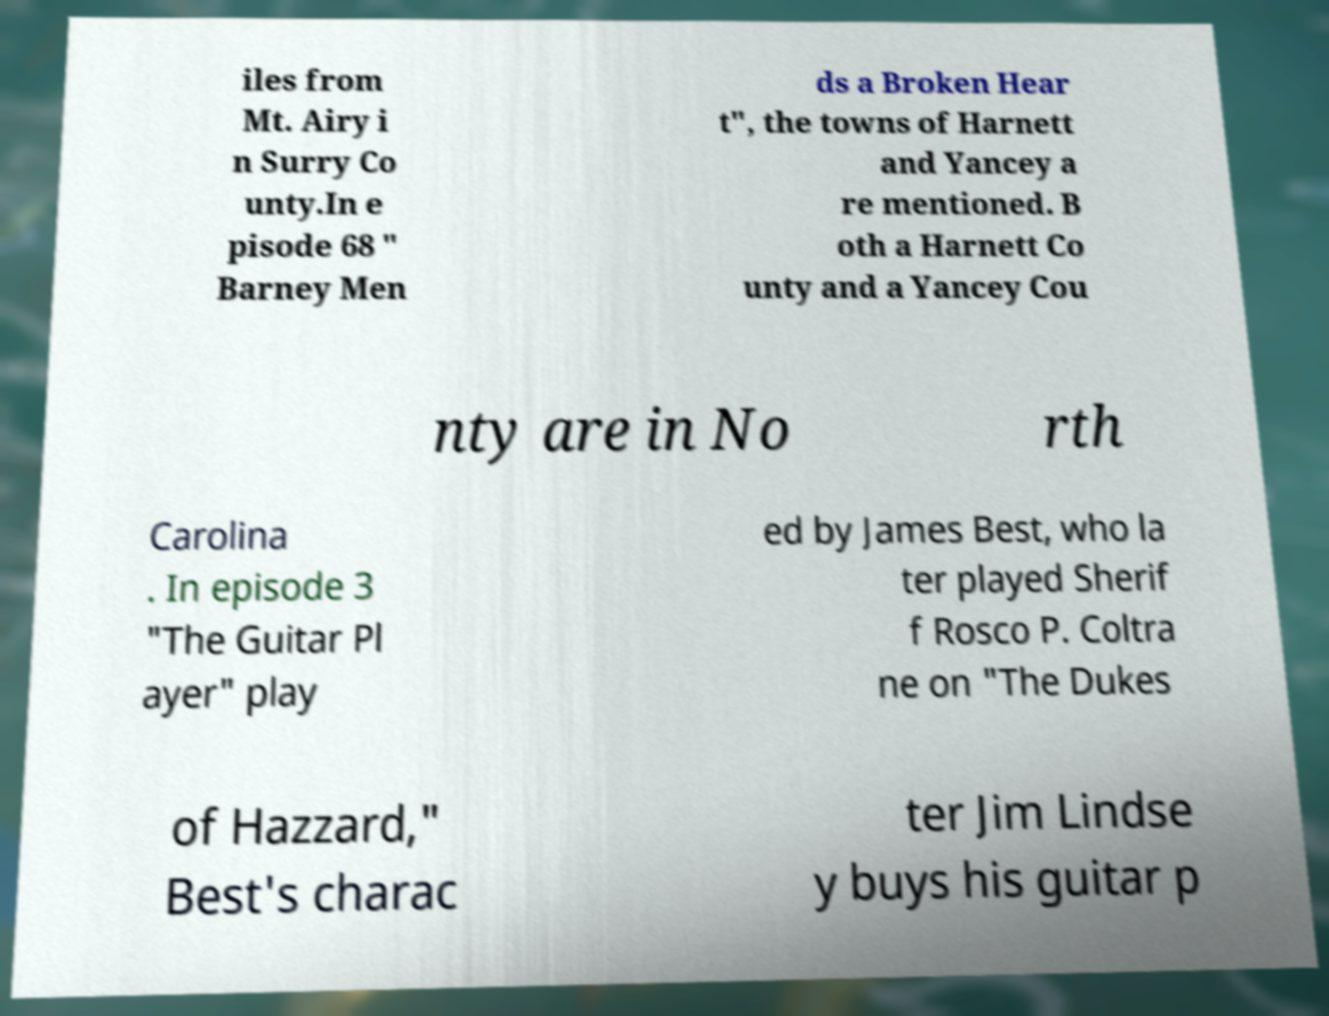I need the written content from this picture converted into text. Can you do that? iles from Mt. Airy i n Surry Co unty.In e pisode 68 " Barney Men ds a Broken Hear t", the towns of Harnett and Yancey a re mentioned. B oth a Harnett Co unty and a Yancey Cou nty are in No rth Carolina . In episode 3 "The Guitar Pl ayer" play ed by James Best, who la ter played Sherif f Rosco P. Coltra ne on "The Dukes of Hazzard," Best's charac ter Jim Lindse y buys his guitar p 